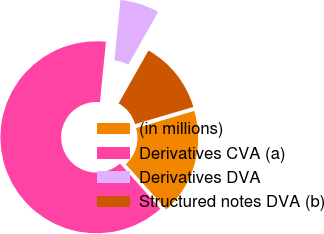<chart> <loc_0><loc_0><loc_500><loc_500><pie_chart><fcel>(in millions)<fcel>Derivatives CVA (a)<fcel>Derivatives DVA<fcel>Structured notes DVA (b)<nl><fcel>17.92%<fcel>63.22%<fcel>6.6%<fcel>12.26%<nl></chart> 